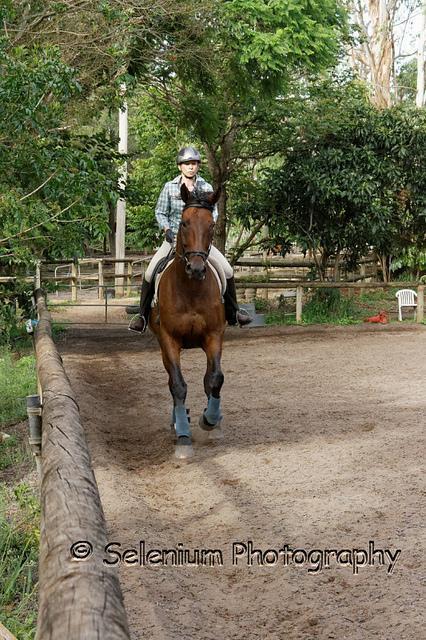In which setting is this person?
Pick the right solution, then justify: 'Answer: answer
Rationale: rationale.'
Options: Factory, farm, city, beach. Answer: farm.
Rationale: The setting is a farm. 